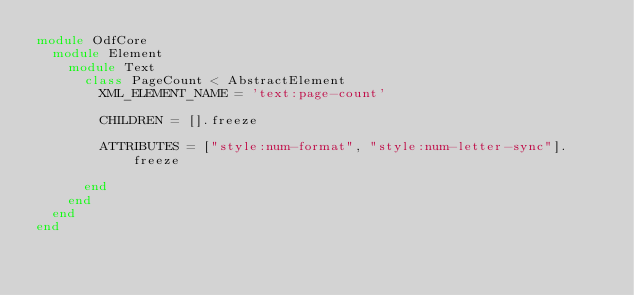Convert code to text. <code><loc_0><loc_0><loc_500><loc_500><_Ruby_>module OdfCore
  module Element
    module Text
      class PageCount < AbstractElement
        XML_ELEMENT_NAME = 'text:page-count'

        CHILDREN = [].freeze

        ATTRIBUTES = ["style:num-format", "style:num-letter-sync"].freeze

      end
    end
  end
end
</code> 